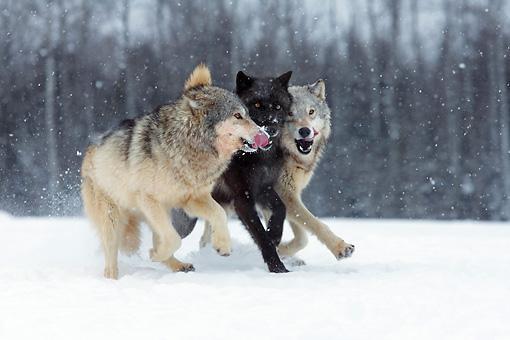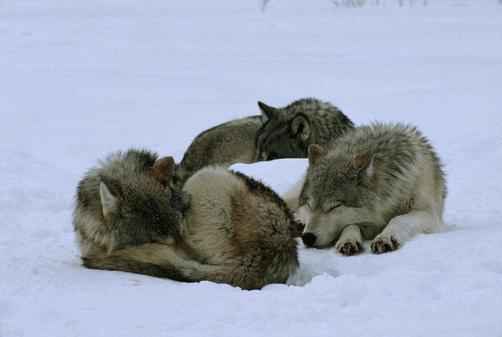The first image is the image on the left, the second image is the image on the right. For the images displayed, is the sentence "The left image contains no more than two wolves." factually correct? Answer yes or no. No. The first image is the image on the left, the second image is the image on the right. Assess this claim about the two images: "An image contains exactly two wolves, which are close together in a snowy scene.". Correct or not? Answer yes or no. No. 